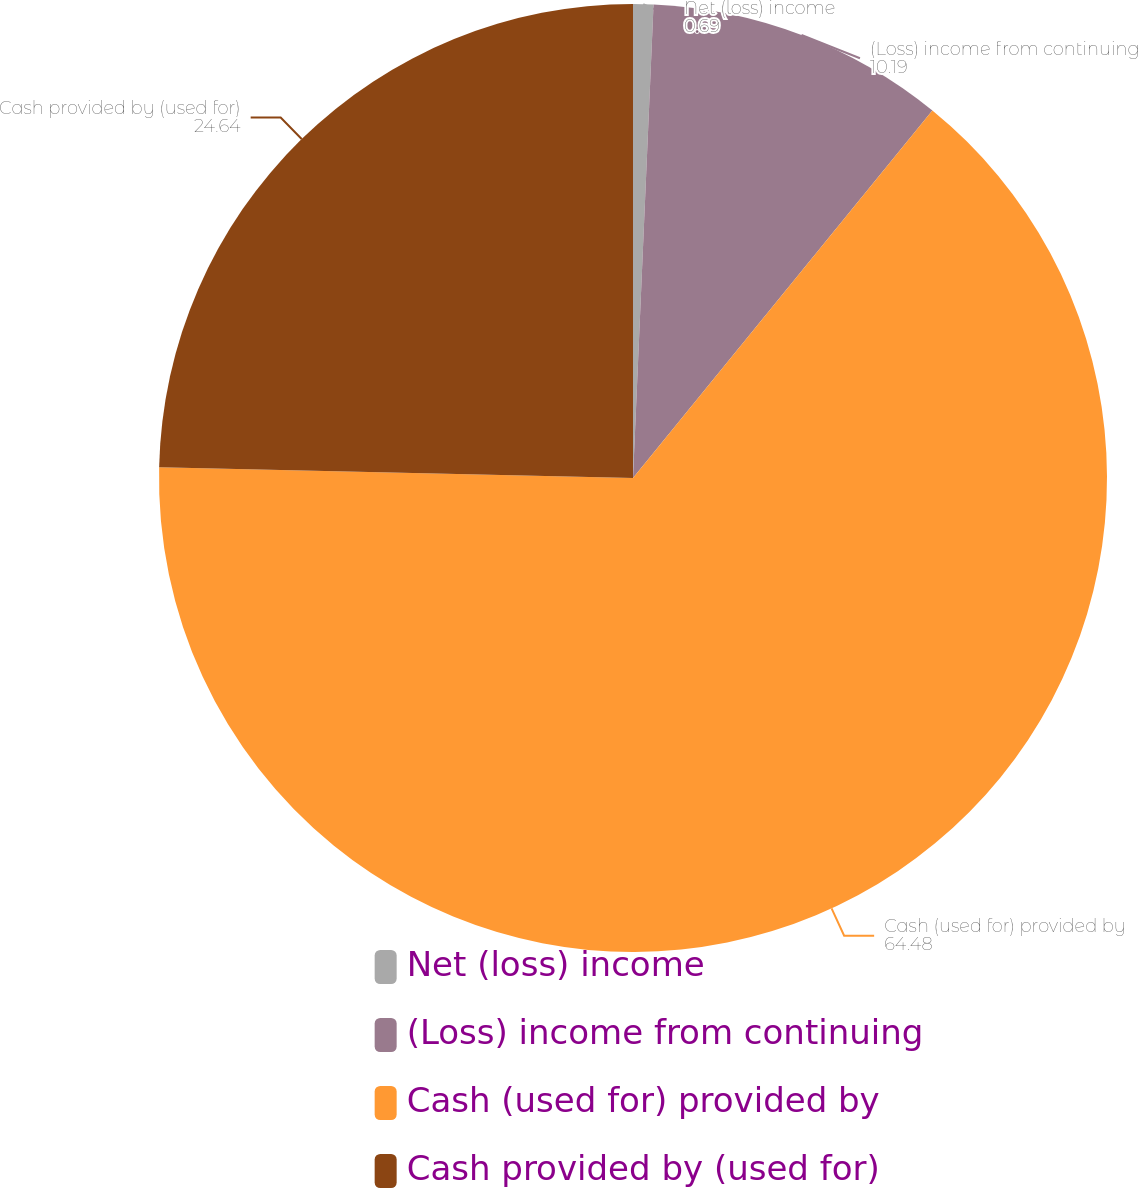Convert chart to OTSL. <chart><loc_0><loc_0><loc_500><loc_500><pie_chart><fcel>Net (loss) income<fcel>(Loss) income from continuing<fcel>Cash (used for) provided by<fcel>Cash provided by (used for)<nl><fcel>0.69%<fcel>10.19%<fcel>64.48%<fcel>24.64%<nl></chart> 